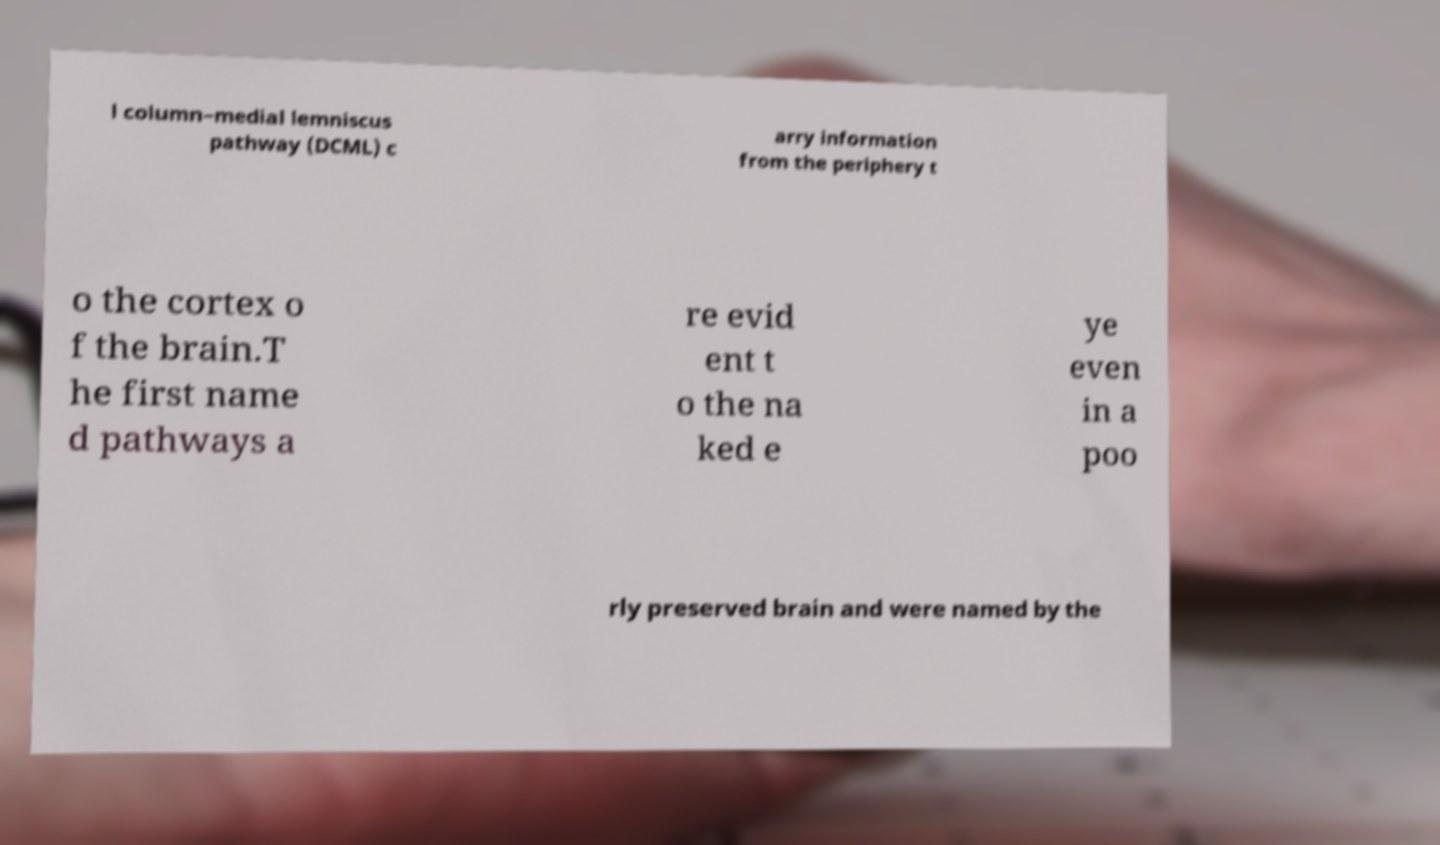What messages or text are displayed in this image? I need them in a readable, typed format. l column–medial lemniscus pathway (DCML) c arry information from the periphery t o the cortex o f the brain.T he first name d pathways a re evid ent t o the na ked e ye even in a poo rly preserved brain and were named by the 